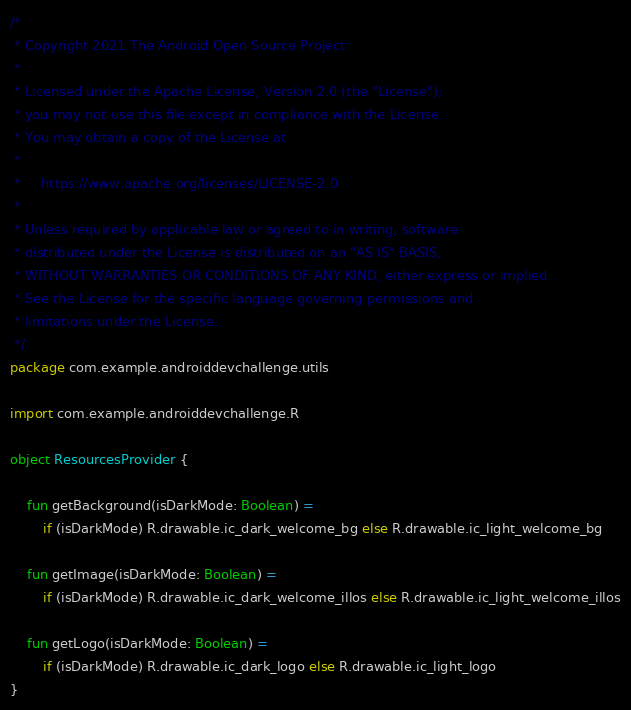Convert code to text. <code><loc_0><loc_0><loc_500><loc_500><_Kotlin_>/*
 * Copyright 2021 The Android Open Source Project
 *
 * Licensed under the Apache License, Version 2.0 (the "License");
 * you may not use this file except in compliance with the License.
 * You may obtain a copy of the License at
 *
 *     https://www.apache.org/licenses/LICENSE-2.0
 *
 * Unless required by applicable law or agreed to in writing, software
 * distributed under the License is distributed on an "AS IS" BASIS,
 * WITHOUT WARRANTIES OR CONDITIONS OF ANY KIND, either express or implied.
 * See the License for the specific language governing permissions and
 * limitations under the License.
 */
package com.example.androiddevchallenge.utils

import com.example.androiddevchallenge.R

object ResourcesProvider {

    fun getBackground(isDarkMode: Boolean) =
        if (isDarkMode) R.drawable.ic_dark_welcome_bg else R.drawable.ic_light_welcome_bg

    fun getImage(isDarkMode: Boolean) =
        if (isDarkMode) R.drawable.ic_dark_welcome_illos else R.drawable.ic_light_welcome_illos

    fun getLogo(isDarkMode: Boolean) =
        if (isDarkMode) R.drawable.ic_dark_logo else R.drawable.ic_light_logo
}
</code> 